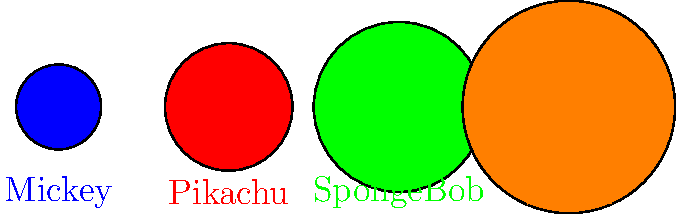Look at the cartoon characters in the picture. Can you put them in order from the smallest to the biggest? Let's look at each character one by one:

1. Mickey (blue circle): This is the smallest circle in the picture.
2. Pikachu (red circle): This circle is a little bigger than Mickey.
3. SpongeBob (green circle): This circle is bigger than Pikachu.
4. Shrek (orange circle): This is the biggest circle in the picture.

To arrange them from smallest to biggest, we start with the smallest (Mickey) and end with the biggest (Shrek).

So, the order from smallest to biggest is:
Mickey, Pikachu, SpongeBob, Shrek
Answer: Mickey, Pikachu, SpongeBob, Shrek 